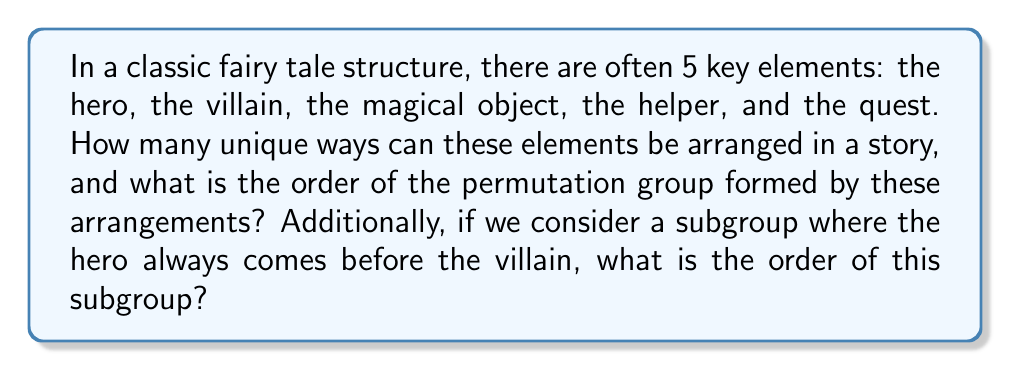Show me your answer to this math problem. Let's approach this step-by-step:

1) First, we need to calculate the number of possible arrangements of the 5 elements. This is a straightforward permutation problem. The number of permutations of n distinct objects is given by n!. In this case:

   Number of permutations = 5! = 5 × 4 × 3 × 2 × 1 = 120

2) The permutations of these elements form a group under the operation of composition. This group is isomorphic to the symmetric group $S_5$. The order of a group is the number of elements in the group. Therefore, the order of this permutation group is 120.

3) For the subgroup where the hero always comes before the villain, we need to consider how this constraint affects the number of permutations:

   a) We can think of the hero and villain as a unit, with 3 other elements.
   b) There are 2! = 2 ways to arrange the hero and villain within their unit.
   c) There are 4! = 24 ways to arrange the unit and the other 3 elements.

4) Therefore, the number of permutations in this subgroup is:

   2 × 24 = 48

5) This subgroup has order 48.
Answer: The order of the full permutation group is 120. The order of the subgroup where the hero always comes before the villain is 48. 